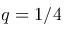<formula> <loc_0><loc_0><loc_500><loc_500>q = 1 / 4</formula> 